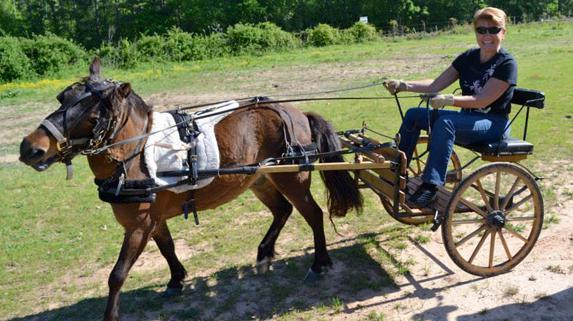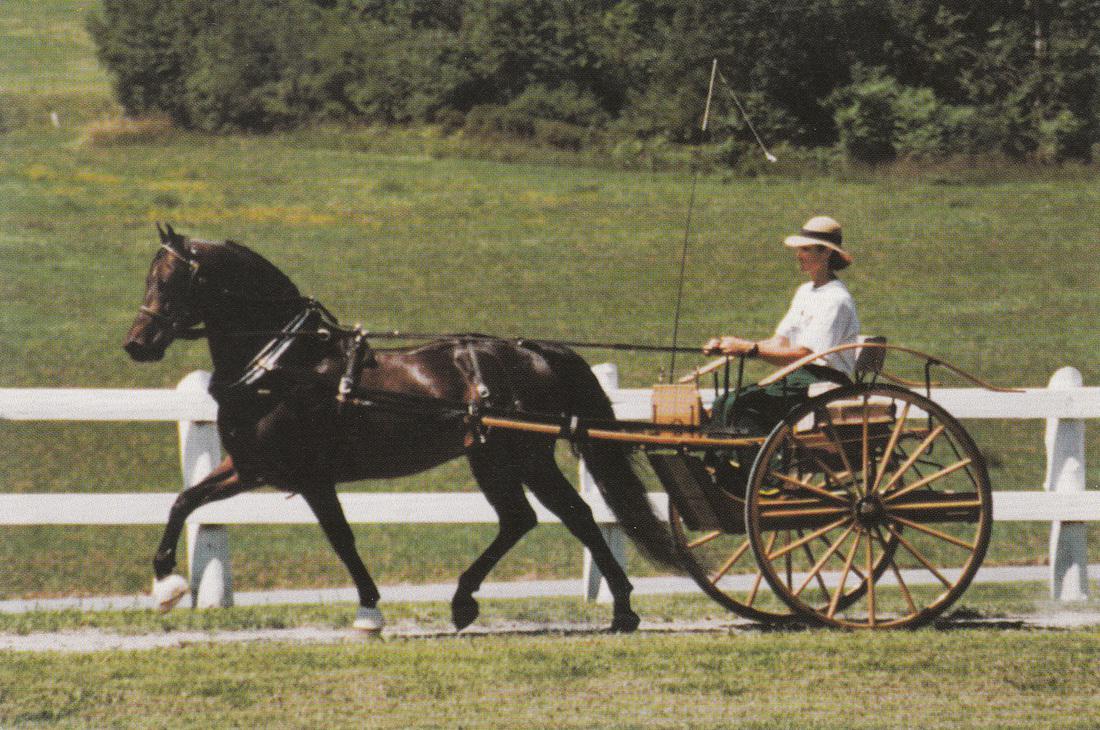The first image is the image on the left, the second image is the image on the right. For the images displayed, is the sentence "A pony's mane hair is flying in the right image." factually correct? Answer yes or no. No. The first image is the image on the left, the second image is the image on the right. For the images shown, is this caption "There is no more than one person in the left image." true? Answer yes or no. Yes. 